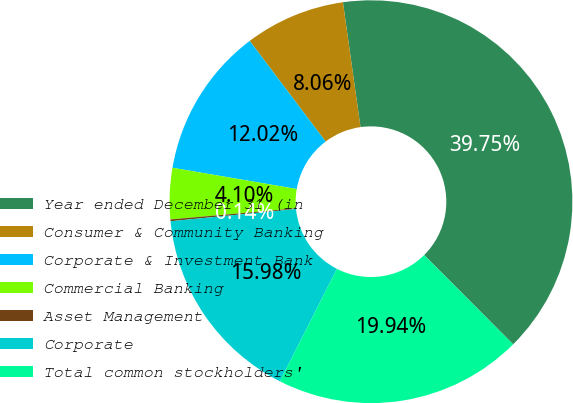<chart> <loc_0><loc_0><loc_500><loc_500><pie_chart><fcel>Year ended December 31 (in<fcel>Consumer & Community Banking<fcel>Corporate & Investment Bank<fcel>Commercial Banking<fcel>Asset Management<fcel>Corporate<fcel>Total common stockholders'<nl><fcel>39.75%<fcel>8.06%<fcel>12.02%<fcel>4.1%<fcel>0.14%<fcel>15.98%<fcel>19.94%<nl></chart> 